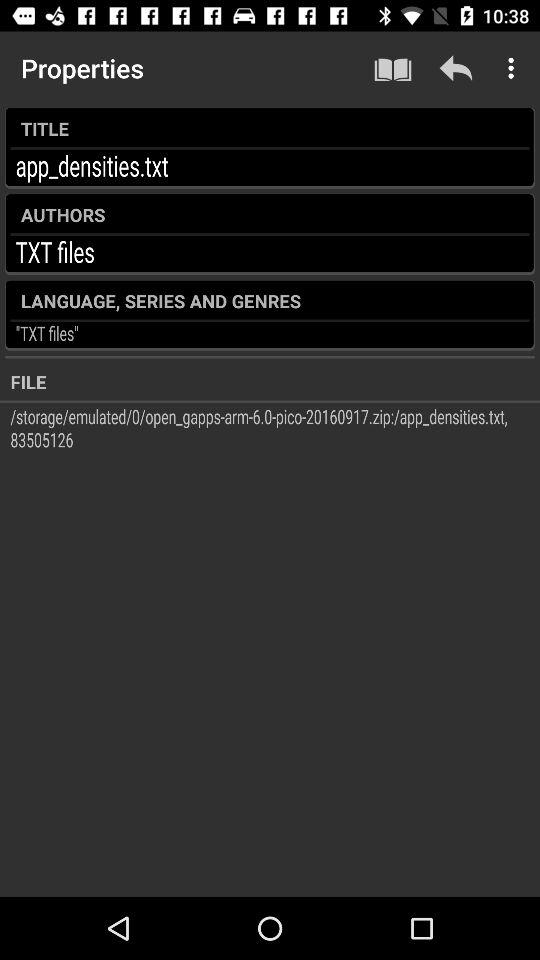What is mentioned in "AUTHORS"? In "AUTHORS", "TXT files" is mentioned. 